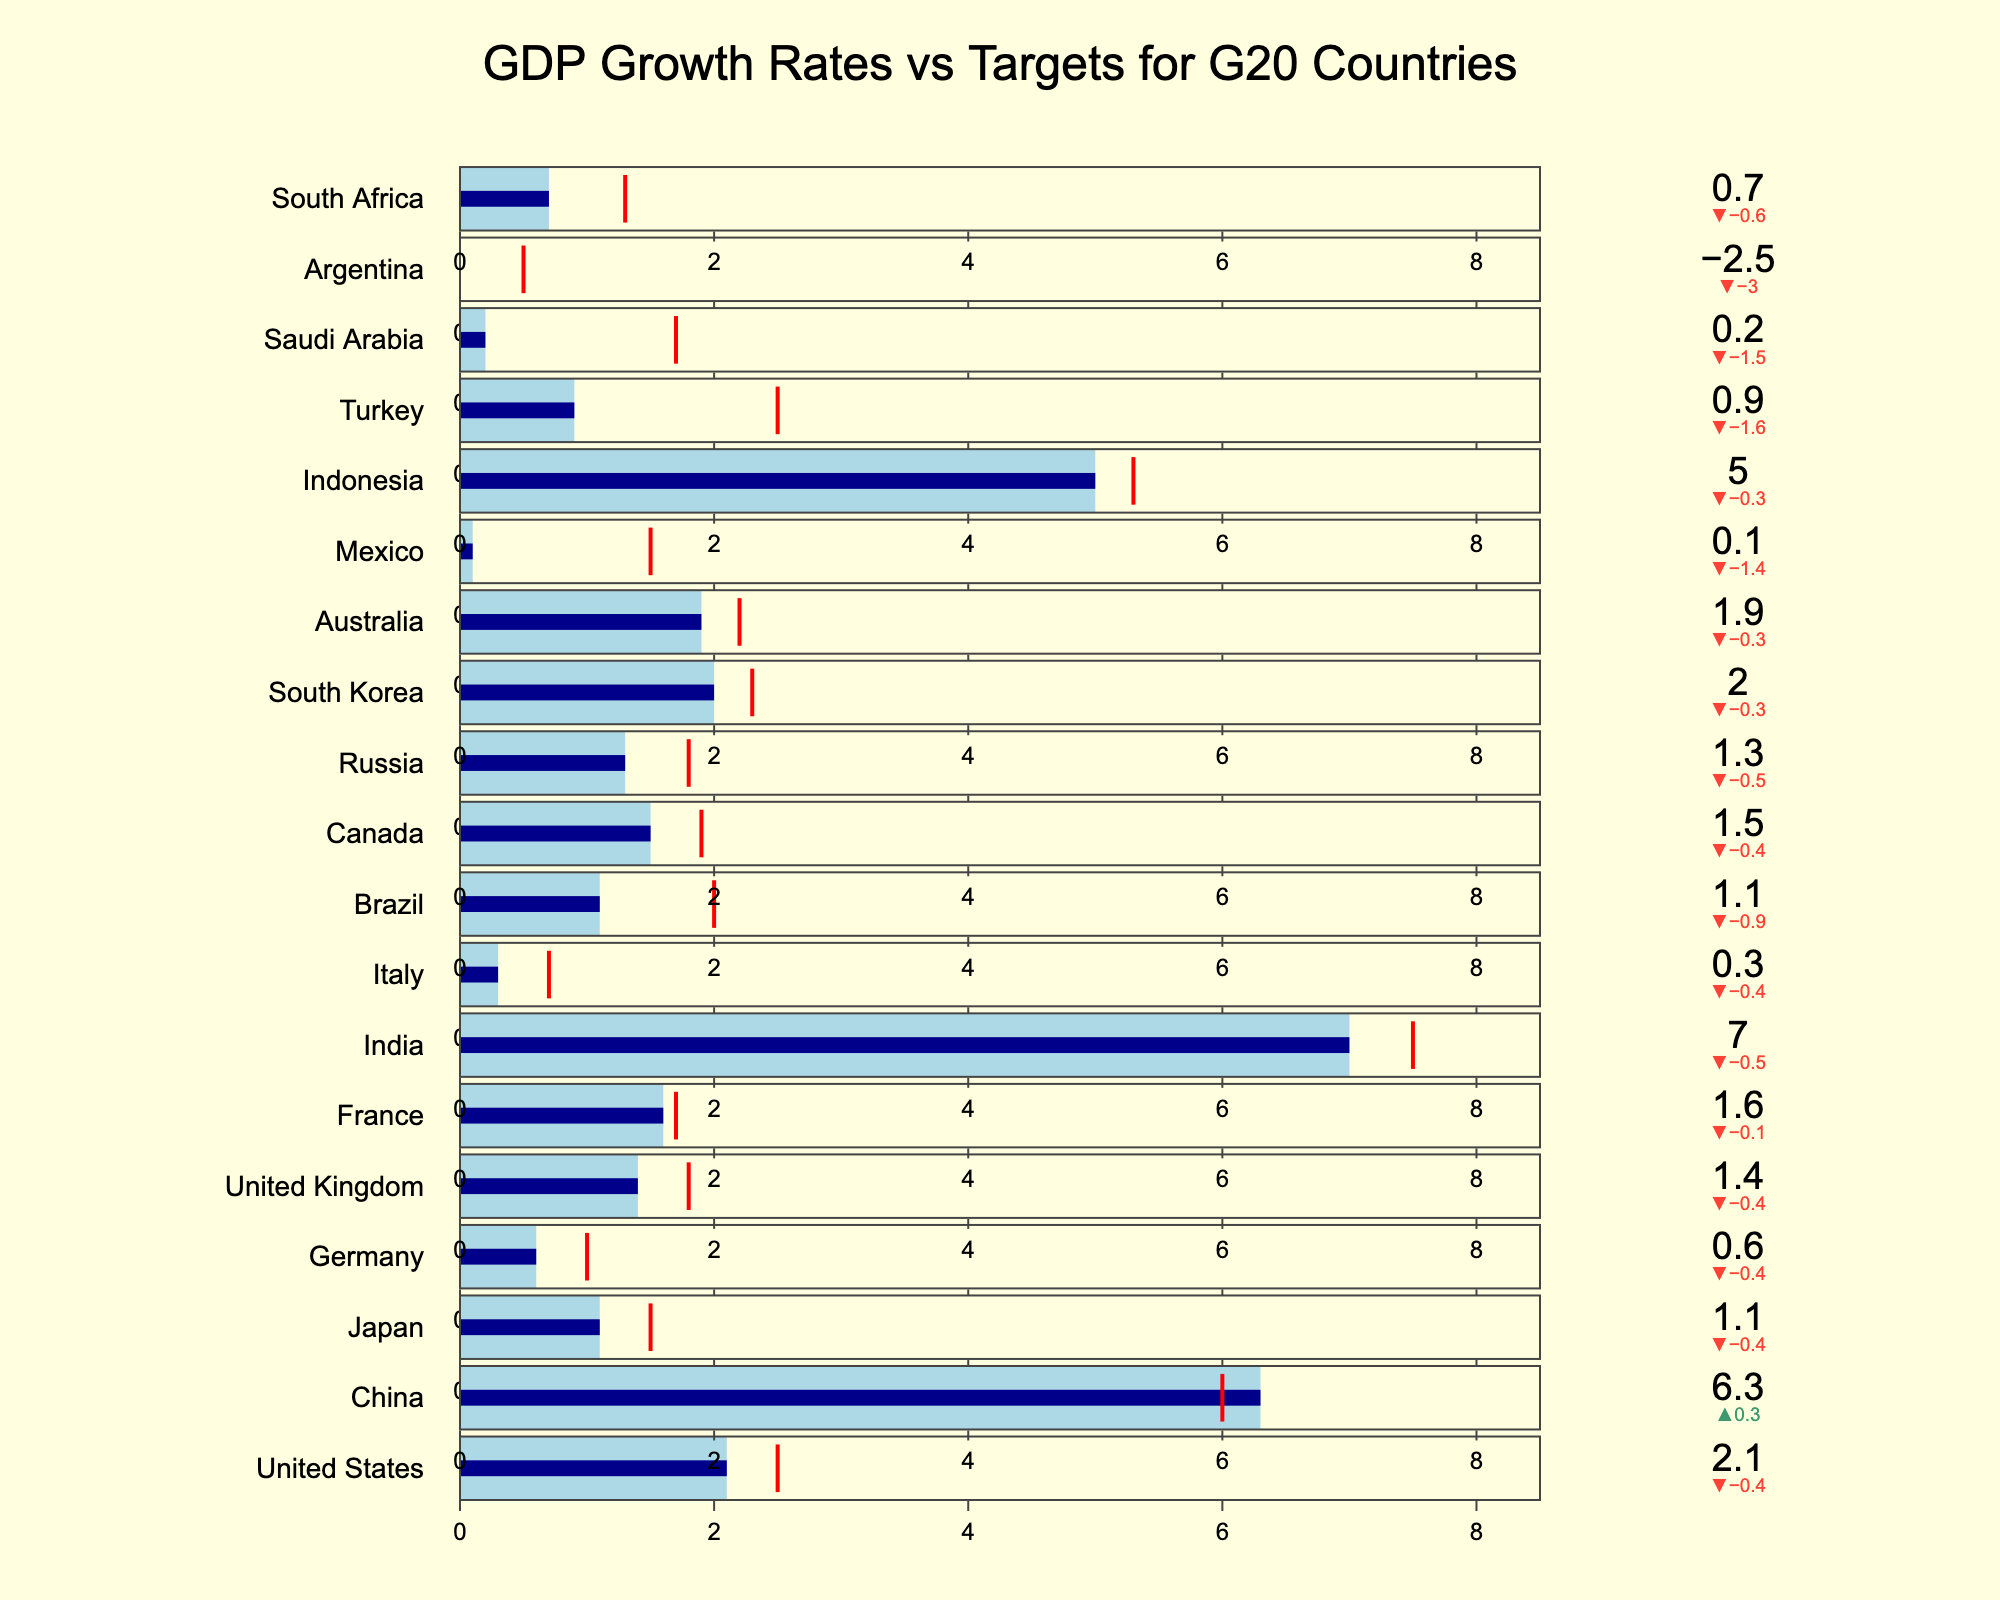What is the title of the chart? The title of the chart is displayed prominently at the top and reads "GDP Growth Rates vs Targets for G20 Countries".
Answer: GDP Growth Rates vs Targets for G20 Countries Which country has the lowest actual GDP growth rate? The country with the lowest actual GDP growth rate is at the bottom of the chart, which is Argentina with an actual growth rate of -2.5%.
Answer: Argentina How many countries have achieved their target GDP growth rate or exceeded it? To answer this, observe if the bar (Actual GDP growth rate) meets or exceeds the threshold (Target GDP growth rate) for each country. These countries are China, France, and India.
Answer: 3 What is the difference between the actual and target GDP growth rates for Mexico? Mexico’s actual GDP growth rate is 0.1% and its target is 1.5%. The difference is calculated by subtracting the actual growth rate from the target growth rate: 1.5 - 0.1.
Answer: 1.4% Which country has the largest positive delta between actual and target GDP growth rates? Look for the country where the actual GDP growth rate exceeds its target the most. China has an actual growth rate of 6.3% with a target of 6.0%, leading to a delta of 0.3%. This is the highest positive delta seen in the chart.
Answer: China Which two countries have the smallest negative difference between their actual and target GDP growth rates? To find the smallest negative differences, identify countries where the target exceeds the actual by the smallest amount. Both Japan (1.5 - 1.1) and South Korea (2.3 - 2.0) have a difference of 0.4%.
Answer: Japan, South Korea What is the total sum of the target GDP growth rates for the G20 countries? Sum the target GDP growth rates for all the countries listed. Adding these together: 2.5 + 6.0 + 1.5 + 1.0 + 1.8 + 1.7 + 7.5 + 0.7 + 2.0 + 1.9 + 1.8 + 2.3 + 2.2 + 1.5 + 5.3 + 2.5 + 1.7 + 0.5 + 1.3. The final sum is 45.7.
Answer: 45.7% Which countries have a target GDP growth rate that is at least double their actual GDP growth rate? Identify countries where the target is at least twice the actual. Mexico (0.1 vs 1.5), Turkey (0.9 vs 2.5), Saudi Arabia (0.2 vs 1.7), and Argentina (-2.5 vs 0.5) meet this criterion.
Answer: Mexico, Turkey, Saudi Arabia, Argentina 